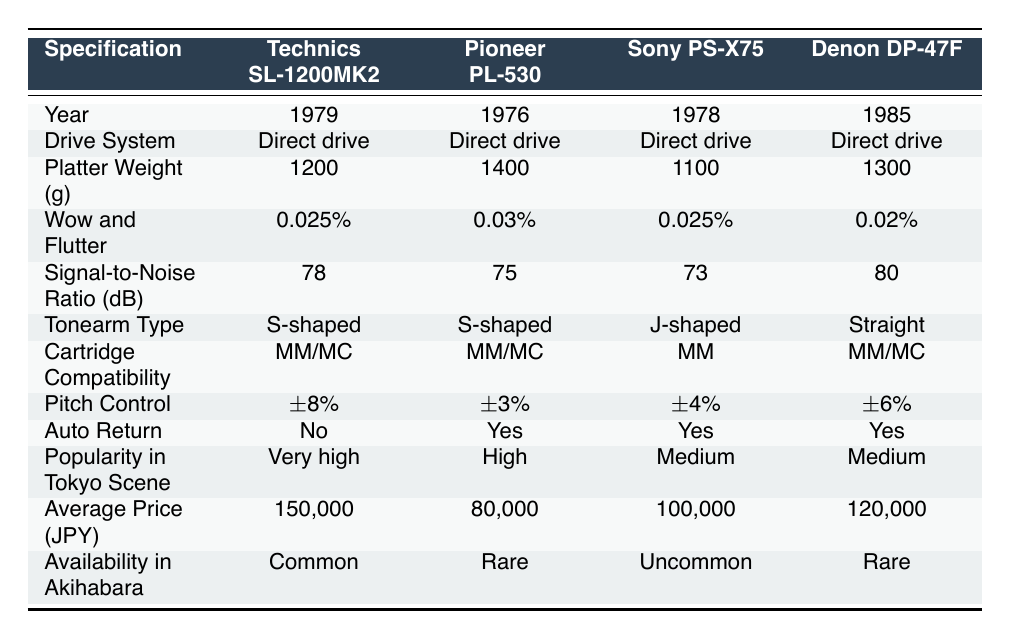What is the average price of the turntables listed in the table? The average price can be calculated by summing the average prices of each turntable (150,000 + 80,000 + 100,000 + 120,000 + 60,000) which equals 610,000 JPY. Then, dividing by the number of turntables (5) gives us an average price of 610,000 / 5 = 122,000 JPY.
Answer: 122,000 JPY Which turntable has the highest signal-to-noise ratio? By examining the signal-to-noise ratio for all the turntables, the Denon DP-47F has the highest ratio at 80 dB.
Answer: Denon DP-47F Does the Pioneer PL-530 have auto return functionality? The table indicates that the auto return feature is marked as "Yes" for the Pioneer PL-530.
Answer: Yes Which turntable is the oldest? The years listed for each model are compared, and the Pioneer PL-530 is the oldest, being produced in 1976.
Answer: Pioneer PL-530 What is the difference in platter weight between the heaviest and lightest turntables? The heaviest turntable is the Pioneer PL-530 at 1400 grams, and the lightest is the AT-LP120 at 1000 grams. The difference is 1400 - 1000 = 400 grams.
Answer: 400 grams Is there any turntable compatible with both MM and MC cartridges? According to the table, both the Technics SL-1200MK2 and the Denon DP-47F are compatible with MM/MC cartridges.
Answer: Yes Which turntable has the lowest popularity in the Tokyo scene? The table notes the average popularity in the Tokyo scene, where the AT-LP120 is classified as having a "Low" popularity.
Answer: AT-LP120 What is the total platter weight of all turntables? The platter weights are summed as follows: 1200 + 1400 + 1100 + 1300 + 1000 = 5000 grams, which represents the total platter weight for all models.
Answer: 5000 grams How many turntables have a pitch control of ±4% or more? Reviewing the pitch control specifications, the Technics SL-1200MK2, Sony PS-X75, and Denon DP-47F all have ±4% or more, making a total of 3 models.
Answer: 3 Which brand's turntable is the most recent model? The most recent model is the AT-LP120, released in 2010, making Audio-Technica the brand with the newest turntable in this table.
Answer: Audio-Technica 